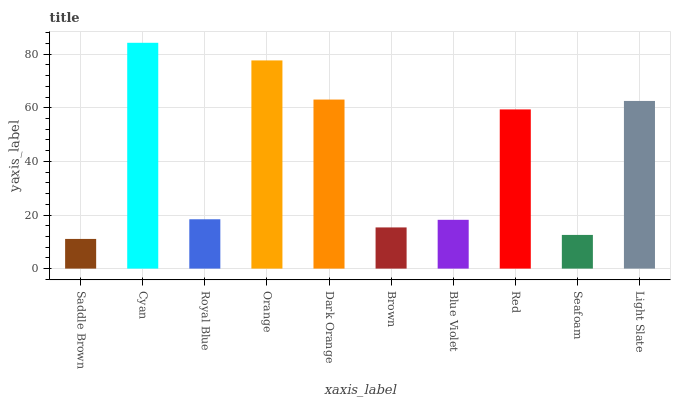Is Saddle Brown the minimum?
Answer yes or no. Yes. Is Cyan the maximum?
Answer yes or no. Yes. Is Royal Blue the minimum?
Answer yes or no. No. Is Royal Blue the maximum?
Answer yes or no. No. Is Cyan greater than Royal Blue?
Answer yes or no. Yes. Is Royal Blue less than Cyan?
Answer yes or no. Yes. Is Royal Blue greater than Cyan?
Answer yes or no. No. Is Cyan less than Royal Blue?
Answer yes or no. No. Is Red the high median?
Answer yes or no. Yes. Is Royal Blue the low median?
Answer yes or no. Yes. Is Orange the high median?
Answer yes or no. No. Is Brown the low median?
Answer yes or no. No. 